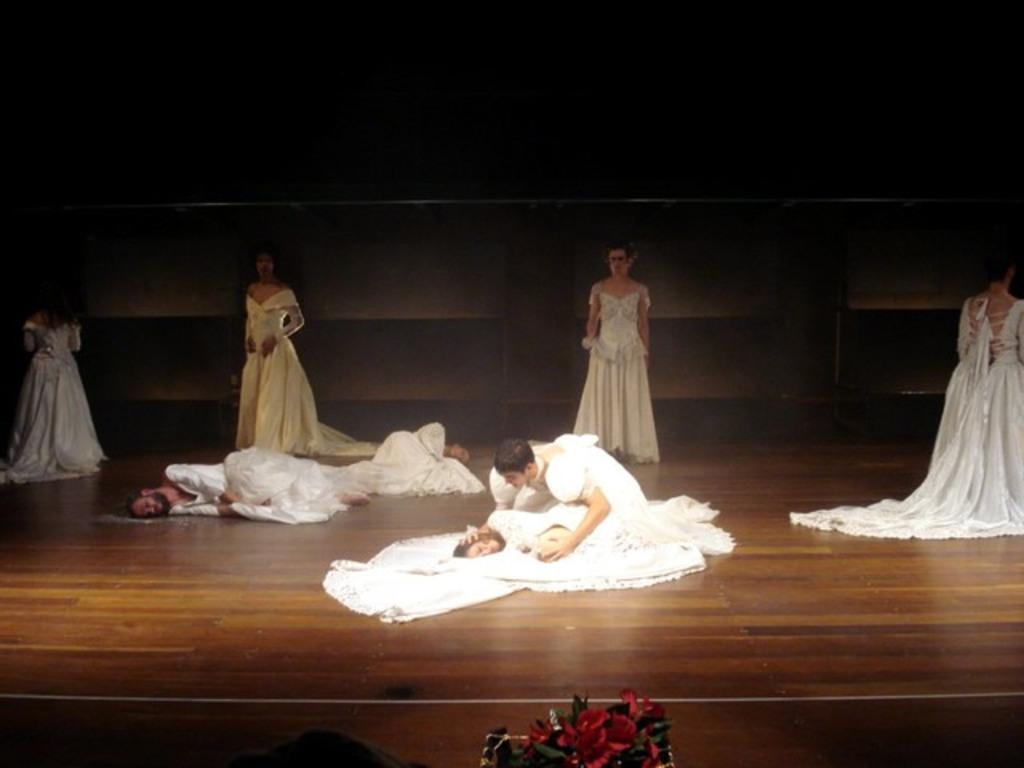In one or two sentences, can you explain what this image depicts? In this picture we can see some people performing on the stage, these people wore costumes, there are three persons laying, at the bottom we can see flowers and leaves. 